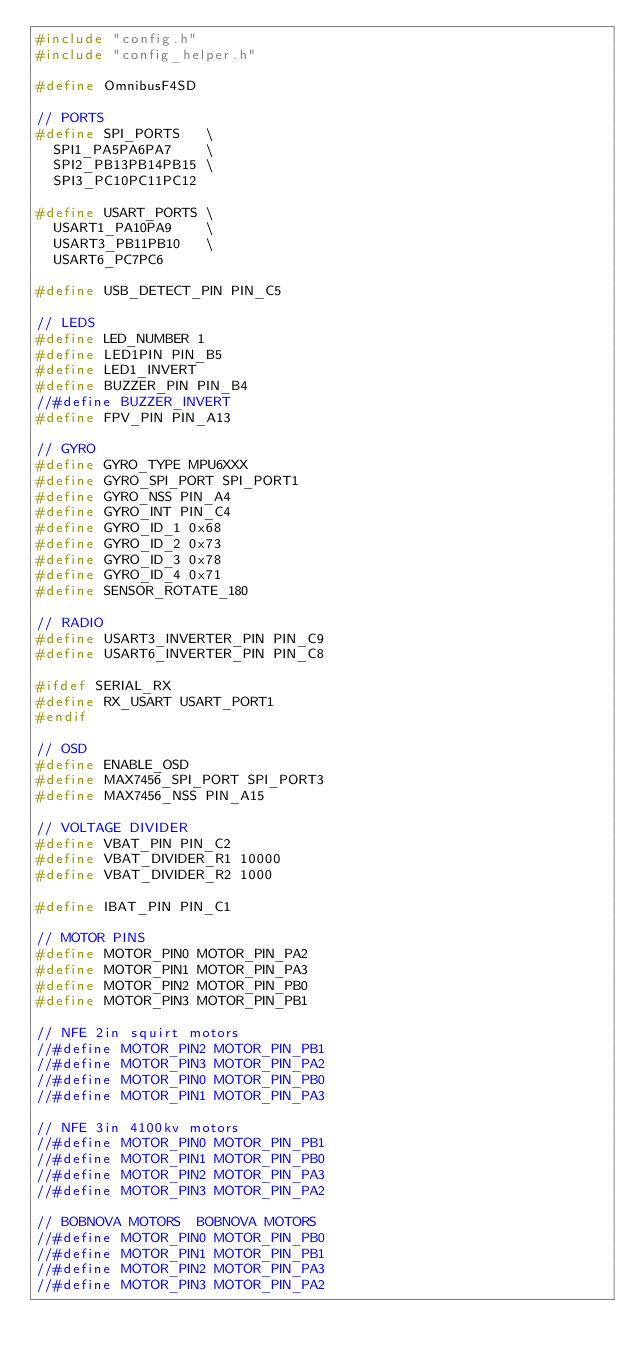Convert code to text. <code><loc_0><loc_0><loc_500><loc_500><_C_>#include "config.h"
#include "config_helper.h"

#define OmnibusF4SD

// PORTS
#define SPI_PORTS   \
  SPI1_PA5PA6PA7    \
  SPI2_PB13PB14PB15 \
  SPI3_PC10PC11PC12

#define USART_PORTS \
  USART1_PA10PA9    \
  USART3_PB11PB10   \
  USART6_PC7PC6

#define USB_DETECT_PIN PIN_C5

// LEDS
#define LED_NUMBER 1
#define LED1PIN PIN_B5
#define LED1_INVERT
#define BUZZER_PIN PIN_B4
//#define BUZZER_INVERT
#define FPV_PIN PIN_A13

// GYRO
#define GYRO_TYPE MPU6XXX
#define GYRO_SPI_PORT SPI_PORT1
#define GYRO_NSS PIN_A4
#define GYRO_INT PIN_C4
#define GYRO_ID_1 0x68
#define GYRO_ID_2 0x73
#define GYRO_ID_3 0x78
#define GYRO_ID_4 0x71
#define SENSOR_ROTATE_180

// RADIO
#define USART3_INVERTER_PIN PIN_C9
#define USART6_INVERTER_PIN PIN_C8

#ifdef SERIAL_RX
#define RX_USART USART_PORT1
#endif

// OSD
#define ENABLE_OSD
#define MAX7456_SPI_PORT SPI_PORT3
#define MAX7456_NSS PIN_A15

// VOLTAGE DIVIDER
#define VBAT_PIN PIN_C2
#define VBAT_DIVIDER_R1 10000
#define VBAT_DIVIDER_R2 1000

#define IBAT_PIN PIN_C1

// MOTOR PINS
#define MOTOR_PIN0 MOTOR_PIN_PA2
#define MOTOR_PIN1 MOTOR_PIN_PA3
#define MOTOR_PIN2 MOTOR_PIN_PB0
#define MOTOR_PIN3 MOTOR_PIN_PB1

// NFE 2in squirt motors
//#define MOTOR_PIN2 MOTOR_PIN_PB1
//#define MOTOR_PIN3 MOTOR_PIN_PA2
//#define MOTOR_PIN0 MOTOR_PIN_PB0
//#define MOTOR_PIN1 MOTOR_PIN_PA3

// NFE 3in 4100kv motors
//#define MOTOR_PIN0 MOTOR_PIN_PB1
//#define MOTOR_PIN1 MOTOR_PIN_PB0
//#define MOTOR_PIN2 MOTOR_PIN_PA3
//#define MOTOR_PIN3 MOTOR_PIN_PA2

// BOBNOVA MOTORS  BOBNOVA MOTORS
//#define MOTOR_PIN0 MOTOR_PIN_PB0
//#define MOTOR_PIN1 MOTOR_PIN_PB1
//#define MOTOR_PIN2 MOTOR_PIN_PA3
//#define MOTOR_PIN3 MOTOR_PIN_PA2
</code> 